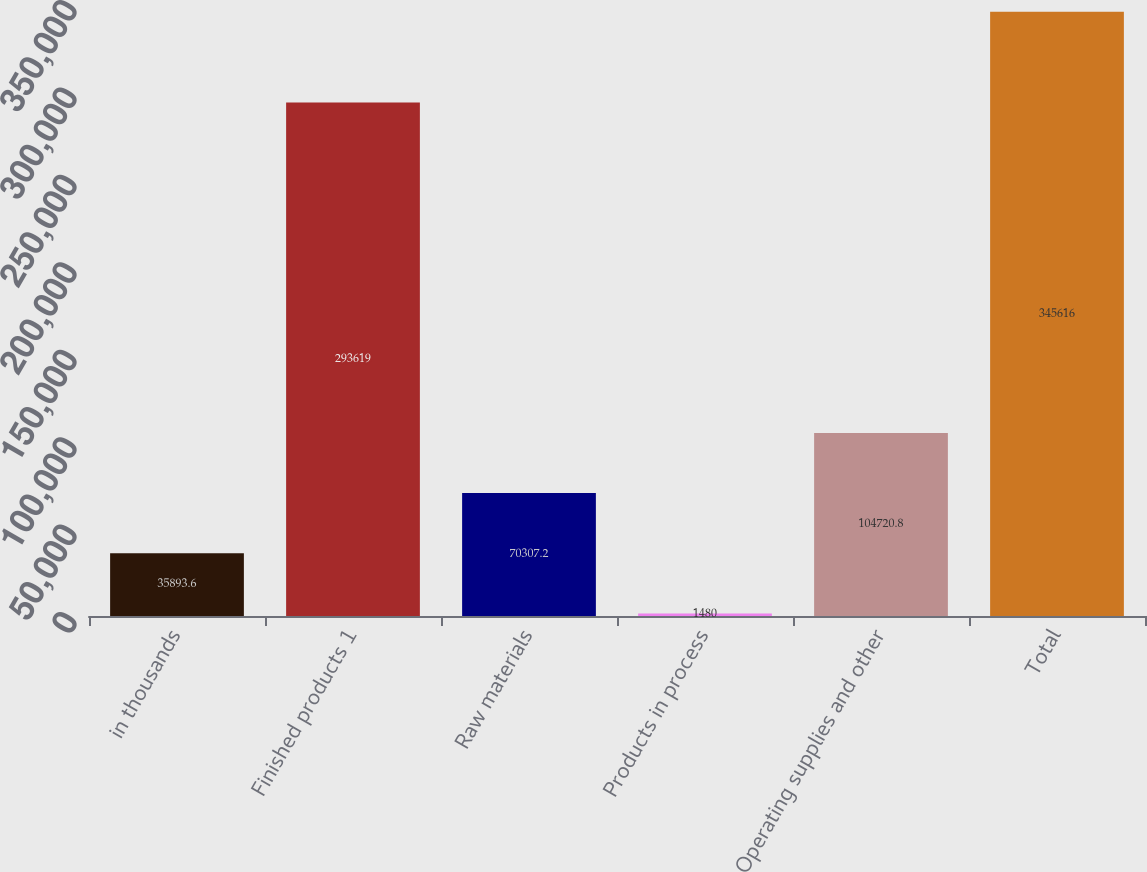<chart> <loc_0><loc_0><loc_500><loc_500><bar_chart><fcel>in thousands<fcel>Finished products 1<fcel>Raw materials<fcel>Products in process<fcel>Operating supplies and other<fcel>Total<nl><fcel>35893.6<fcel>293619<fcel>70307.2<fcel>1480<fcel>104721<fcel>345616<nl></chart> 